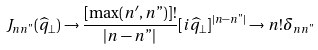Convert formula to latex. <formula><loc_0><loc_0><loc_500><loc_500>J _ { n n " } ( \widehat { q } _ { \bot } ) \rightarrow \frac { [ \max ( n ^ { \prime } , n " ) ] ! } { | n - n " | } [ i \widehat { q } _ { \bot } ] ^ { | n - n " | } \rightarrow n ! \delta _ { n n " }</formula> 